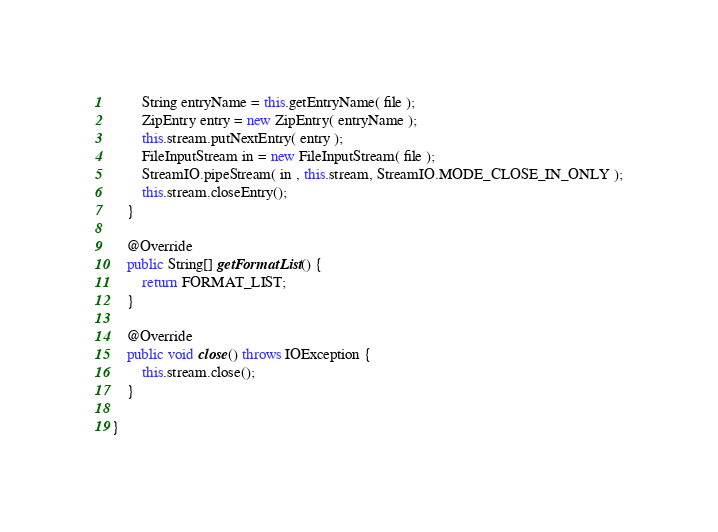<code> <loc_0><loc_0><loc_500><loc_500><_Java_>		String entryName = this.getEntryName( file );
    	ZipEntry entry = new ZipEntry( entryName );
    	this.stream.putNextEntry( entry );
    	FileInputStream in = new FileInputStream( file );
    	StreamIO.pipeStream( in , this.stream, StreamIO.MODE_CLOSE_IN_ONLY );
    	this.stream.closeEntry();
	}

	@Override
	public String[] getFormatList() {
		return FORMAT_LIST;
	}

	@Override
	public void close() throws IOException {
		this.stream.close();
	}
	
}

</code> 